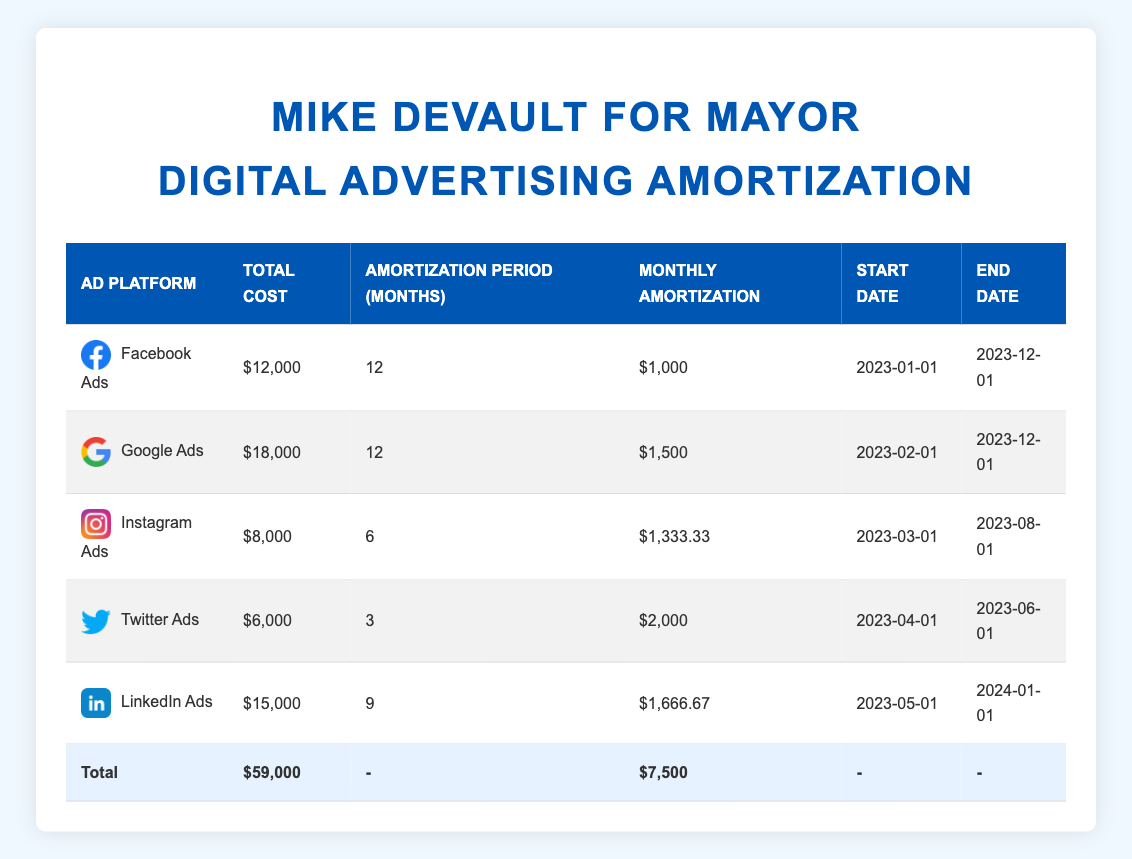What is the total cost for the "Mike DeVault for Mayor" campaign's digital advertising expenses? The table lists individual costs for each of the ad platforms used in the campaign. By adding up the total costs of Facebook Ads ($12,000), Google Ads ($18,000), Instagram Ads ($8,000), Twitter Ads ($6,000), and LinkedIn Ads ($15,000), we can find the total: 12000 + 18000 + 8000 + 6000 + 15000 = 59000.
Answer: 59000 How much is the monthly amortization for Google Ads? The table shows the monthly amortization for each advertising platform. For Google Ads, the monthly amortization is specified as $1,500.
Answer: 1500 Is the total cost for Instagram Ads less than the monthly amortization of LinkedIn Ads? From the table, the total cost for Instagram Ads is $8,000, and the monthly amortization for LinkedIn Ads is $1,666.67. We check if $8,000 is less than $1,666.67: this is not true, so the answer is no.
Answer: No What is the number of months required for the amortization of Twitter Ads? According to the table, the amortization period for Twitter Ads is explicitly stated as 3 months.
Answer: 3 If we begin the amortization for all platforms, how much total expense would there be by August 2023? We will look at the end dates for ads that started before August 2023: Facebook Ads and Google Ads end later than August. Instagram Ads have an end date of August 1, 2023; Twitter Ads ends June 1, 2023 and LinkedIn Ads ends January 2024. Summing total costs up to August: Facebook ($12,000) + Google ($18,000) + Instagram ($8,000) + Twitter ($6,000) = $44,000. LinkedIn is not included since it ends in 2024.
Answer: 44000 What is the highest monthly amortization amount among all ad platforms? By reviewing the monthly amortization values, we see that Facebook and Google have amortizations of $1,000 and $1,500 respectively, while Instagram has $1,333.33, Twitter has $2,000, and LinkedIn has $1,666.67. The highest monthly amortization is $2,000 for Twitter Ads.
Answer: 2000 